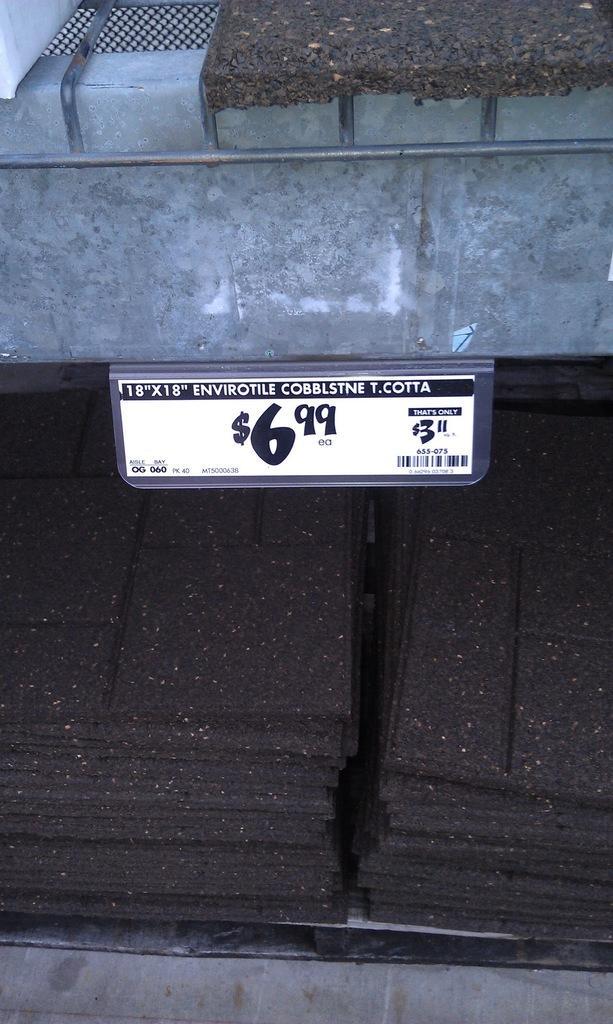In one or two sentences, can you explain what this image depicts? In this image we can see rectangular shape black color things are arranged in the rack and one price tag is also there. 